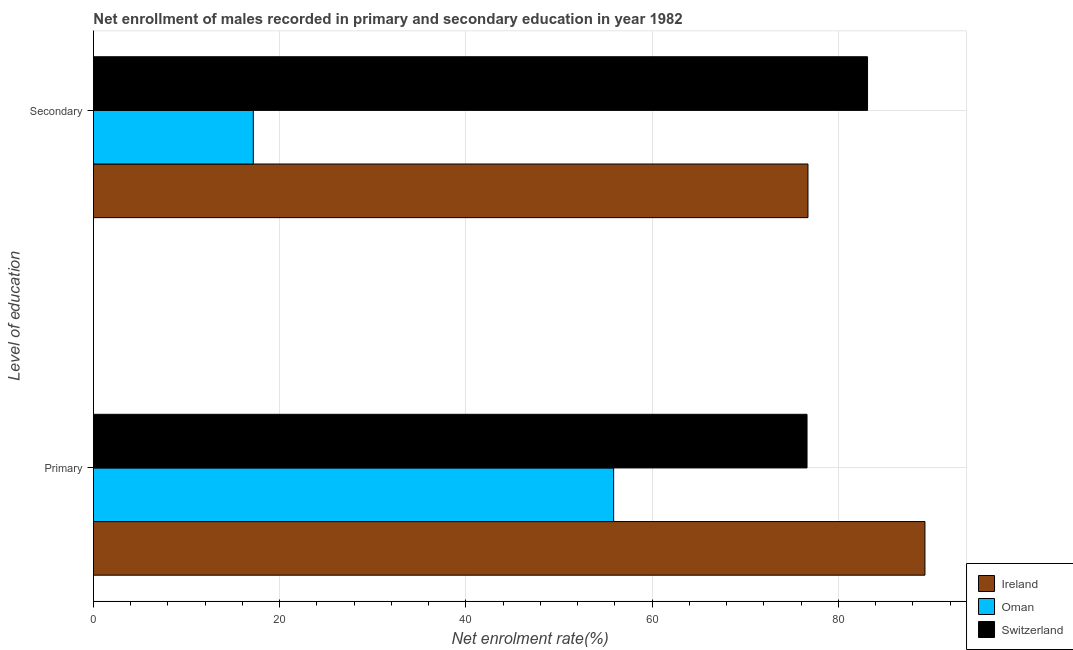How many different coloured bars are there?
Ensure brevity in your answer.  3. What is the label of the 1st group of bars from the top?
Offer a terse response. Secondary. What is the enrollment rate in secondary education in Ireland?
Offer a terse response. 76.72. Across all countries, what is the maximum enrollment rate in secondary education?
Ensure brevity in your answer.  83.12. Across all countries, what is the minimum enrollment rate in secondary education?
Ensure brevity in your answer.  17.16. In which country was the enrollment rate in secondary education maximum?
Offer a terse response. Switzerland. In which country was the enrollment rate in primary education minimum?
Offer a very short reply. Oman. What is the total enrollment rate in secondary education in the graph?
Make the answer very short. 177.01. What is the difference between the enrollment rate in secondary education in Ireland and that in Switzerland?
Give a very brief answer. -6.4. What is the difference between the enrollment rate in primary education in Switzerland and the enrollment rate in secondary education in Ireland?
Your answer should be compact. -0.1. What is the average enrollment rate in primary education per country?
Give a very brief answer. 73.92. What is the difference between the enrollment rate in secondary education and enrollment rate in primary education in Ireland?
Keep it short and to the point. -12.56. In how many countries, is the enrollment rate in secondary education greater than 52 %?
Provide a succinct answer. 2. What is the ratio of the enrollment rate in primary education in Ireland to that in Switzerland?
Your answer should be very brief. 1.17. Is the enrollment rate in secondary education in Ireland less than that in Oman?
Provide a succinct answer. No. What does the 1st bar from the top in Primary represents?
Your answer should be compact. Switzerland. What does the 2nd bar from the bottom in Primary represents?
Make the answer very short. Oman. How many bars are there?
Make the answer very short. 6. How many countries are there in the graph?
Your response must be concise. 3. What is the difference between two consecutive major ticks on the X-axis?
Your answer should be compact. 20. Are the values on the major ticks of X-axis written in scientific E-notation?
Provide a short and direct response. No. Does the graph contain grids?
Make the answer very short. Yes. Where does the legend appear in the graph?
Offer a very short reply. Bottom right. How many legend labels are there?
Keep it short and to the point. 3. How are the legend labels stacked?
Offer a very short reply. Vertical. What is the title of the graph?
Ensure brevity in your answer.  Net enrollment of males recorded in primary and secondary education in year 1982. Does "Sint Maarten (Dutch part)" appear as one of the legend labels in the graph?
Offer a very short reply. No. What is the label or title of the X-axis?
Offer a very short reply. Net enrolment rate(%). What is the label or title of the Y-axis?
Your answer should be compact. Level of education. What is the Net enrolment rate(%) in Ireland in Primary?
Your answer should be very brief. 89.28. What is the Net enrolment rate(%) in Oman in Primary?
Make the answer very short. 55.86. What is the Net enrolment rate(%) in Switzerland in Primary?
Keep it short and to the point. 76.62. What is the Net enrolment rate(%) of Ireland in Secondary?
Your response must be concise. 76.72. What is the Net enrolment rate(%) in Oman in Secondary?
Offer a very short reply. 17.16. What is the Net enrolment rate(%) of Switzerland in Secondary?
Offer a very short reply. 83.12. Across all Level of education, what is the maximum Net enrolment rate(%) of Ireland?
Your answer should be compact. 89.28. Across all Level of education, what is the maximum Net enrolment rate(%) of Oman?
Your answer should be compact. 55.86. Across all Level of education, what is the maximum Net enrolment rate(%) in Switzerland?
Offer a very short reply. 83.12. Across all Level of education, what is the minimum Net enrolment rate(%) in Ireland?
Your response must be concise. 76.72. Across all Level of education, what is the minimum Net enrolment rate(%) in Oman?
Your answer should be compact. 17.16. Across all Level of education, what is the minimum Net enrolment rate(%) in Switzerland?
Provide a short and direct response. 76.62. What is the total Net enrolment rate(%) of Ireland in the graph?
Offer a very short reply. 166.01. What is the total Net enrolment rate(%) of Oman in the graph?
Make the answer very short. 73.02. What is the total Net enrolment rate(%) in Switzerland in the graph?
Provide a short and direct response. 159.74. What is the difference between the Net enrolment rate(%) of Ireland in Primary and that in Secondary?
Your answer should be very brief. 12.56. What is the difference between the Net enrolment rate(%) of Oman in Primary and that in Secondary?
Provide a short and direct response. 38.69. What is the difference between the Net enrolment rate(%) in Switzerland in Primary and that in Secondary?
Offer a terse response. -6.5. What is the difference between the Net enrolment rate(%) of Ireland in Primary and the Net enrolment rate(%) of Oman in Secondary?
Keep it short and to the point. 72.12. What is the difference between the Net enrolment rate(%) of Ireland in Primary and the Net enrolment rate(%) of Switzerland in Secondary?
Offer a terse response. 6.16. What is the difference between the Net enrolment rate(%) of Oman in Primary and the Net enrolment rate(%) of Switzerland in Secondary?
Keep it short and to the point. -27.27. What is the average Net enrolment rate(%) in Ireland per Level of education?
Offer a very short reply. 83. What is the average Net enrolment rate(%) of Oman per Level of education?
Make the answer very short. 36.51. What is the average Net enrolment rate(%) in Switzerland per Level of education?
Your response must be concise. 79.87. What is the difference between the Net enrolment rate(%) of Ireland and Net enrolment rate(%) of Oman in Primary?
Give a very brief answer. 33.43. What is the difference between the Net enrolment rate(%) of Ireland and Net enrolment rate(%) of Switzerland in Primary?
Keep it short and to the point. 12.66. What is the difference between the Net enrolment rate(%) in Oman and Net enrolment rate(%) in Switzerland in Primary?
Make the answer very short. -20.77. What is the difference between the Net enrolment rate(%) in Ireland and Net enrolment rate(%) in Oman in Secondary?
Ensure brevity in your answer.  59.56. What is the difference between the Net enrolment rate(%) of Ireland and Net enrolment rate(%) of Switzerland in Secondary?
Give a very brief answer. -6.4. What is the difference between the Net enrolment rate(%) in Oman and Net enrolment rate(%) in Switzerland in Secondary?
Make the answer very short. -65.96. What is the ratio of the Net enrolment rate(%) in Ireland in Primary to that in Secondary?
Your answer should be compact. 1.16. What is the ratio of the Net enrolment rate(%) in Oman in Primary to that in Secondary?
Your answer should be very brief. 3.25. What is the ratio of the Net enrolment rate(%) of Switzerland in Primary to that in Secondary?
Provide a short and direct response. 0.92. What is the difference between the highest and the second highest Net enrolment rate(%) of Ireland?
Give a very brief answer. 12.56. What is the difference between the highest and the second highest Net enrolment rate(%) in Oman?
Your answer should be very brief. 38.69. What is the difference between the highest and the second highest Net enrolment rate(%) in Switzerland?
Provide a short and direct response. 6.5. What is the difference between the highest and the lowest Net enrolment rate(%) in Ireland?
Make the answer very short. 12.56. What is the difference between the highest and the lowest Net enrolment rate(%) of Oman?
Ensure brevity in your answer.  38.69. What is the difference between the highest and the lowest Net enrolment rate(%) of Switzerland?
Your answer should be very brief. 6.5. 